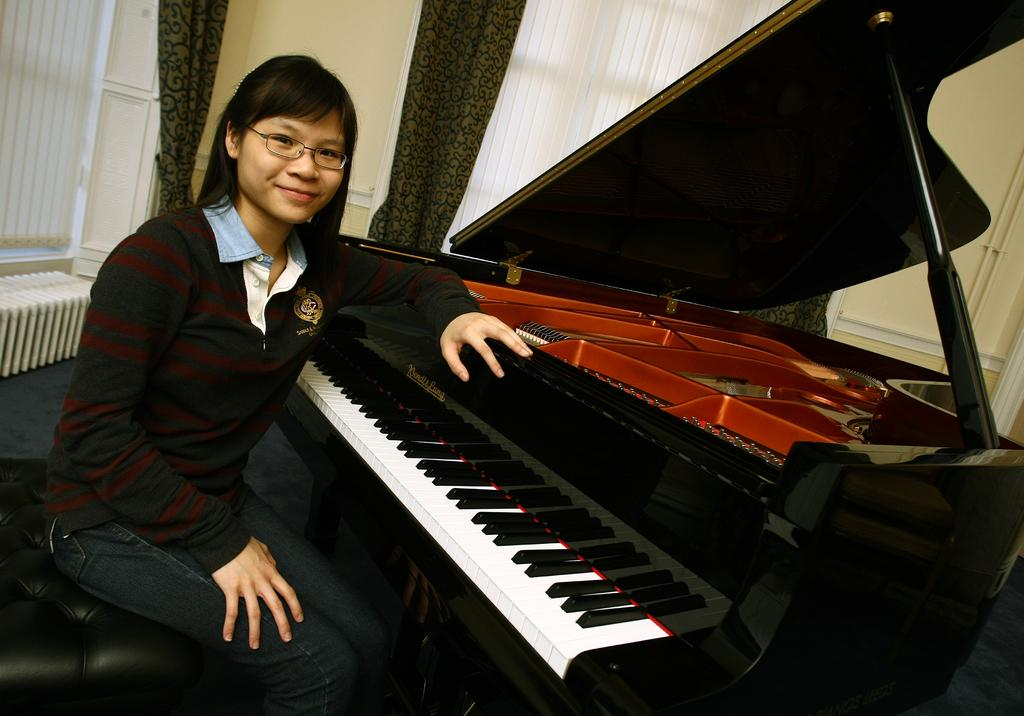Who is present in the image? There is a woman in the image. What is the woman sitting beside? The woman is sitting beside a piano. What type of clothing is the woman wearing? The woman is wearing a T-shirt and denim pants. What can be seen in the background of the image? There are windows and curtains in the background of the image. What degree does the woman hold in the image? There is no information about the woman's degree in the image. What type of cream is being used by the woman in the image? There is no cream present in the image. 